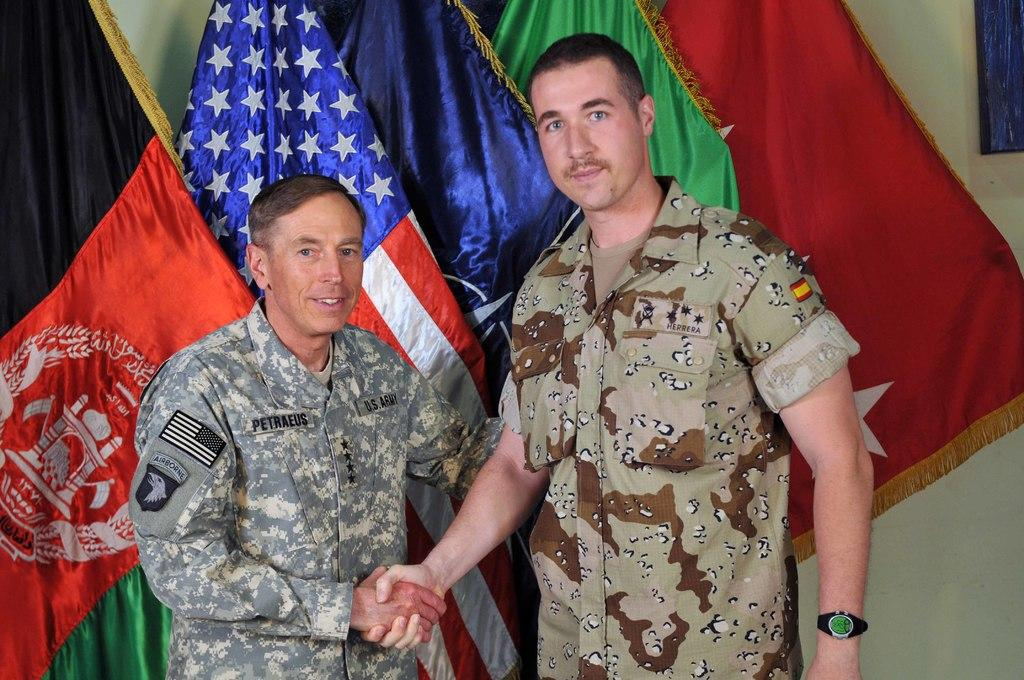<image>
Summarize the visual content of the image. A U.S. Army member shakes hands with a military man next to some flags. 